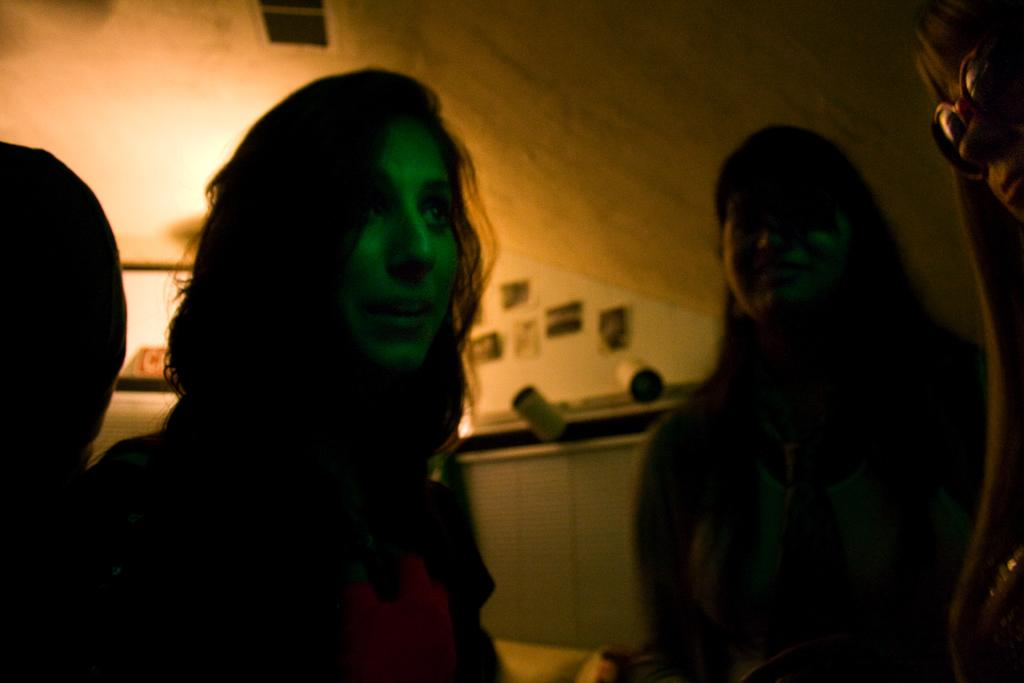How many women are in the foreground of the image? There are four women in the foreground of the image. What is the lighting condition in the image? The women are standing in the dark. What can be seen in the background of the image? There is a wall and frames in the background. Are there any light sources visible in the image? Yes, there are lights in the background. How many dogs are visible in the image? There are no dogs present in the image. Can you compare the size of the bottle to the women in the image? There is no bottle present in the image, so it cannot be compared to the women. 